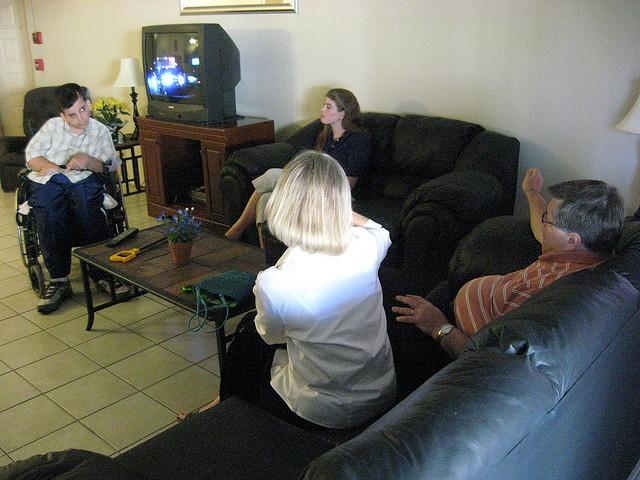What is the couple celebrating?
Answer briefly. Anniversary. How many people are there?
Write a very short answer. 4. Is one of the people in a wheelchair?
Write a very short answer. Yes. What are the people sitting on?
Short answer required. Couch. 